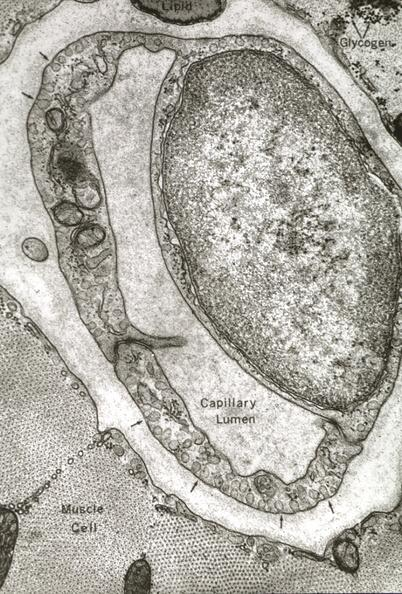what is present?
Answer the question using a single word or phrase. Capillary 